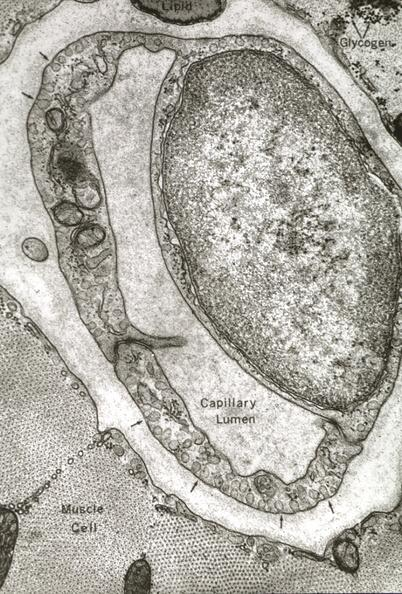what is present?
Answer the question using a single word or phrase. Capillary 